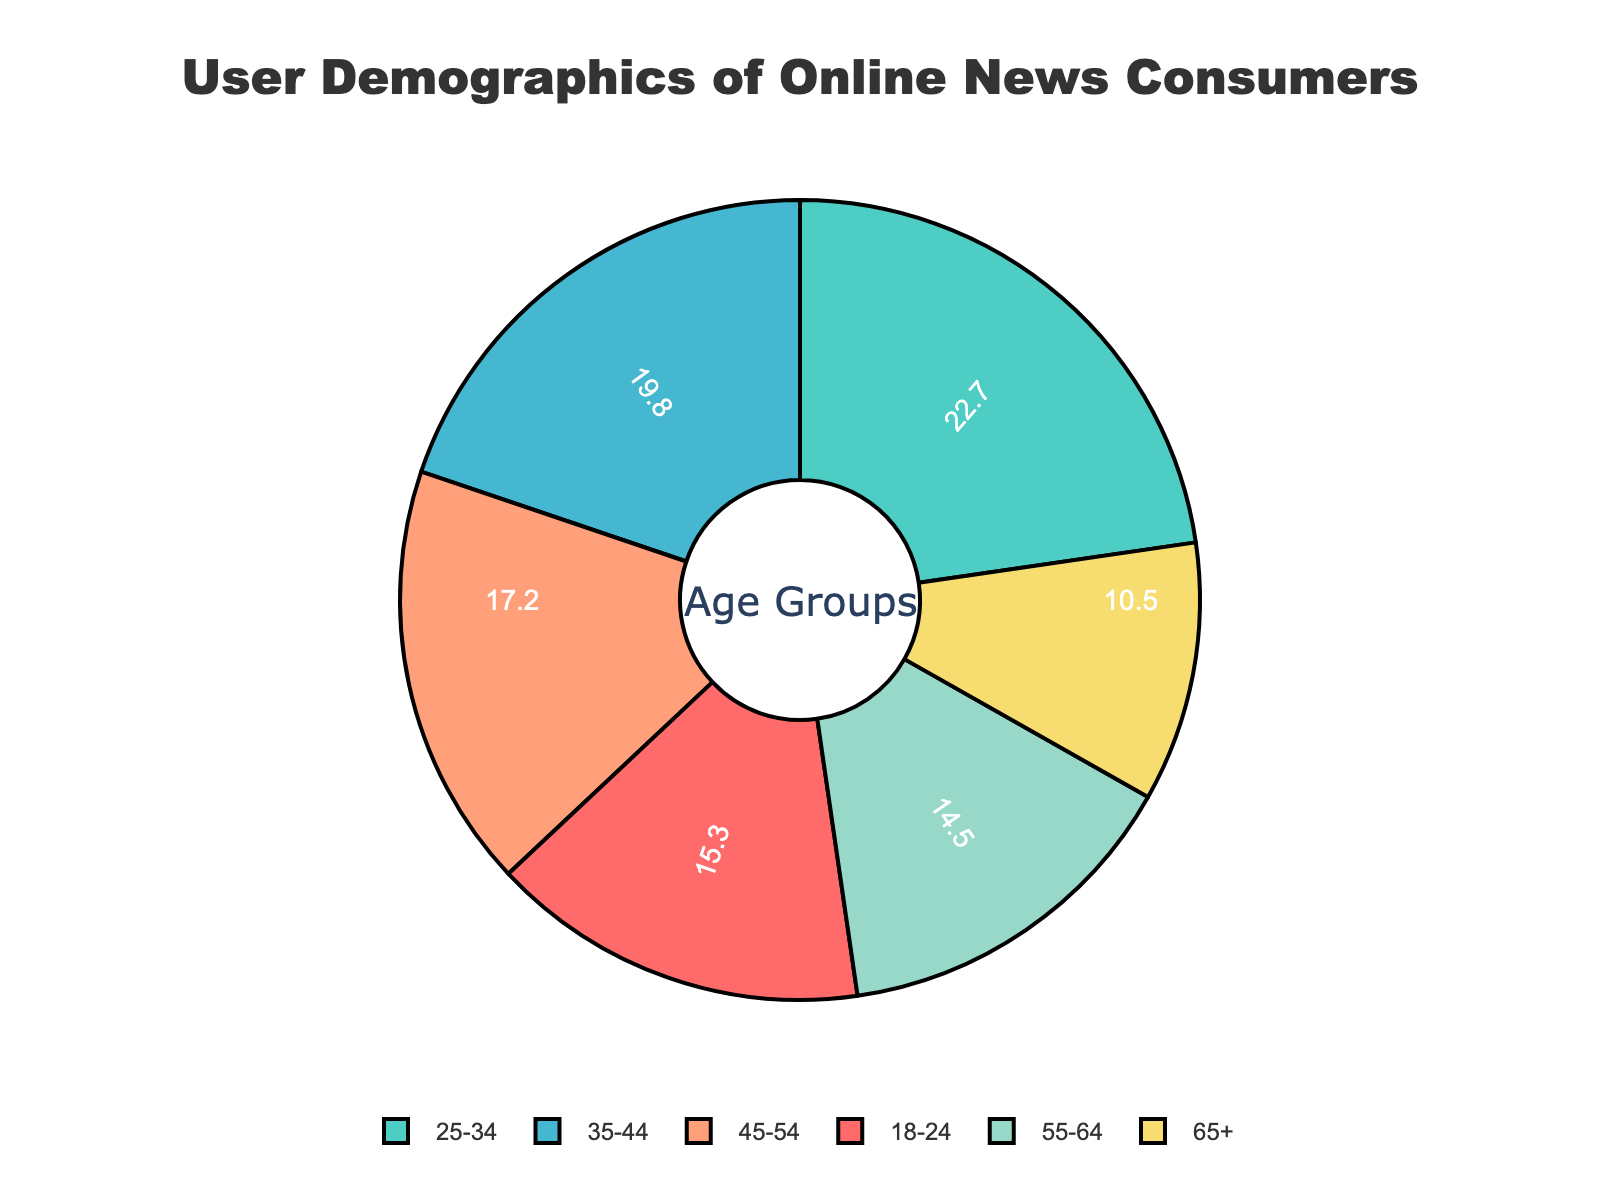What age group has the highest percentage of online news consumers? The figure shows a pie chart with percentage labels for different age groups. The segment with the highest percentage will be the one with the largest number. From the figure, the 25-34 age group has the highest percentage with 22.7%.
Answer: 25-34 Which age group has the smallest percentage of online news consumers? By examining the pie chart, we identify the segment with the smallest numerical value. The 65+ age group has the smallest percentage, which is 10.5%.
Answer: 65+ What's the combined percentage of online news consumers aged 18-24 and 55-64? To get the combined percentage for these age groups, add the individual percentages: 15.3% (for 18-24) + 14.5% (for 55-64). The sum is 29.8%.
Answer: 29.8% Which group has a larger percentage: 45-54 or 35-44? Comparing the percentages for these two age groups; 45-54 has 17.2% while 35-44 has 19.8%. Since 19.8% is greater than 17.2%, the 35-44 age group has a larger percentage.
Answer: 35-44 What's the ratio of the 25-34 age group to the 65+ age group? The percentage for the 25-34 age group is 22.7, and 10.5 for the 65+ age group. Therefore, the ratio is 22.7 / 10.5, which equals approximately 2.16:1.
Answer: 2.16:1 Identify the color representing the 18-24 age group in the pie chart. We look at the pie chart and match the color corresponding to the 18-24 age group. From the legend, the 18-24 age group is depicted in red.
Answer: Red How much greater is the percentage of the 25-34 age group compared to the 55-64 age group? Subtract the percentage of the 55-64 age group from that of the 25-34 age group: 22.7 - 14.5, which equals 8.2%.
Answer: 8.2% What is the sum of the percentages of the age groups 35-44, 45-54 and 55-64? Add the percentages: 19.8% (35-44) + 17.2% (45-54) + 14.5% (55-64). The sum is 51.5%.
Answer: 51.5% Which age group is represented by the green segment in the pie chart? Examining the pie chart, the green segment corresponds to the 25-34 age group according to the legend.
Answer: 25-34 